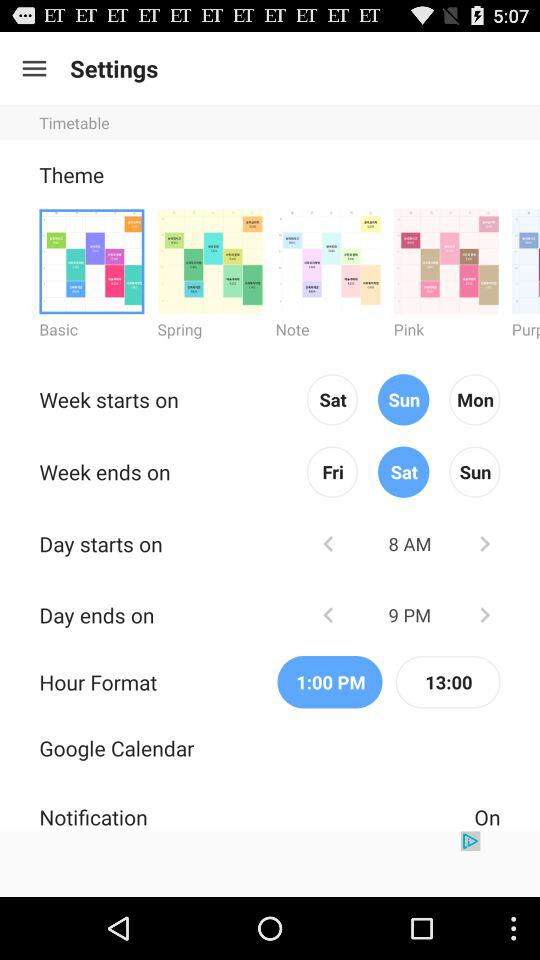What is the hour format? The hour formats are 1:00 PM and 13:00. 